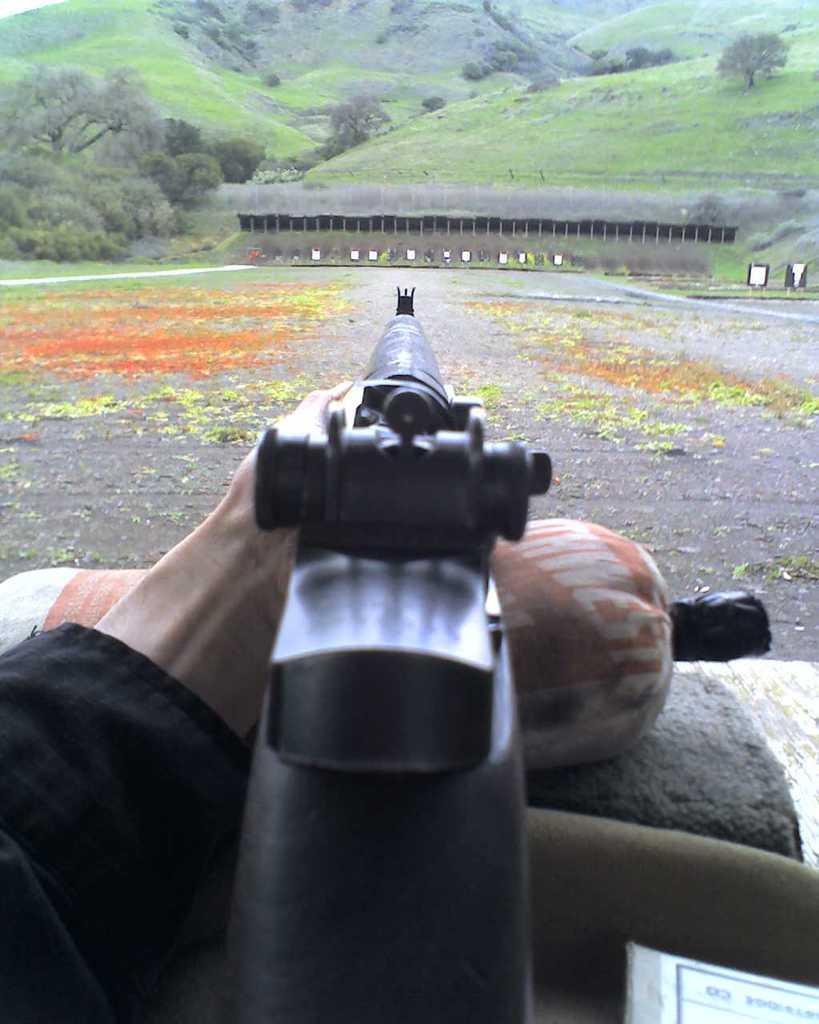Describe this image in one or two sentences. In this picture I can observe a gun placed on the cylindrical pillow. In the background I can observe some trees and hills. 